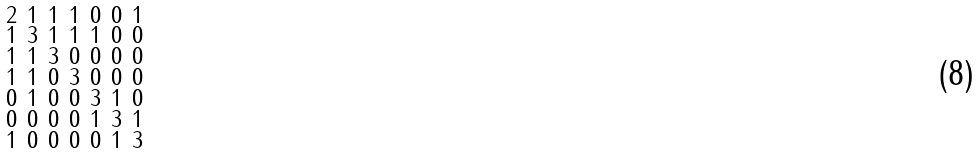<formula> <loc_0><loc_0><loc_500><loc_500>\begin{smallmatrix} 2 & 1 & 1 & 1 & 0 & 0 & 1 \\ 1 & 3 & 1 & 1 & 1 & 0 & 0 \\ 1 & 1 & 3 & 0 & 0 & 0 & 0 \\ 1 & 1 & 0 & 3 & 0 & 0 & 0 \\ 0 & 1 & 0 & 0 & 3 & 1 & 0 \\ 0 & 0 & 0 & 0 & 1 & 3 & 1 \\ 1 & 0 & 0 & 0 & 0 & 1 & 3 \end{smallmatrix}</formula> 